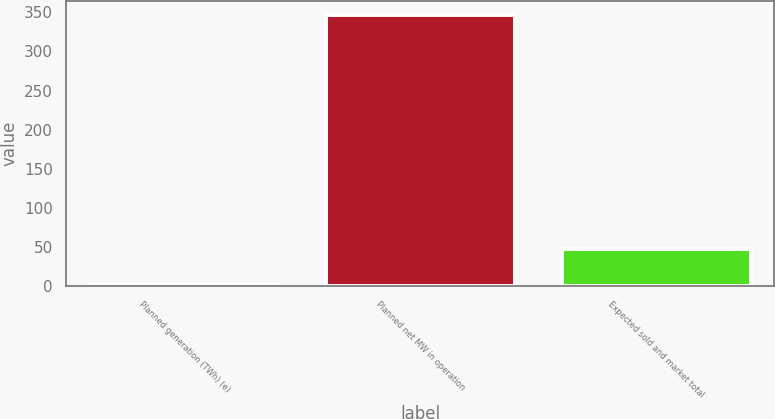Convert chart to OTSL. <chart><loc_0><loc_0><loc_500><loc_500><bar_chart><fcel>Planned generation (TWh) (e)<fcel>Planned net MW in operation<fcel>Expected sold and market total<nl><fcel>2.9<fcel>347<fcel>48.1<nl></chart> 